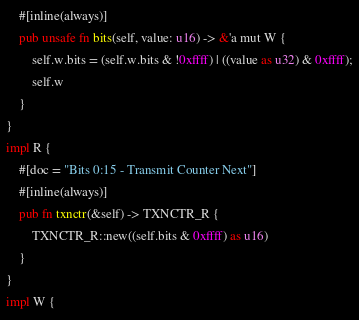Convert code to text. <code><loc_0><loc_0><loc_500><loc_500><_Rust_>    #[inline(always)]
    pub unsafe fn bits(self, value: u16) -> &'a mut W {
        self.w.bits = (self.w.bits & !0xffff) | ((value as u32) & 0xffff);
        self.w
    }
}
impl R {
    #[doc = "Bits 0:15 - Transmit Counter Next"]
    #[inline(always)]
    pub fn txnctr(&self) -> TXNCTR_R {
        TXNCTR_R::new((self.bits & 0xffff) as u16)
    }
}
impl W {</code> 